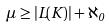Convert formula to latex. <formula><loc_0><loc_0><loc_500><loc_500>\mu \geq | L ( K ) | + \aleph _ { 0 }</formula> 